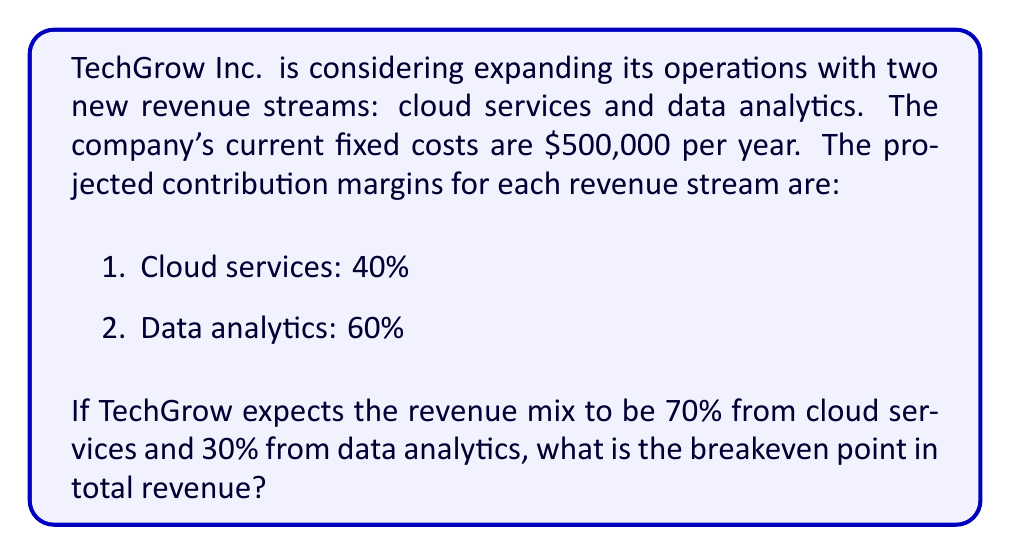Can you answer this question? To solve this problem, we'll follow these steps:

1. Calculate the weighted average contribution margin:
   Let $x$ be the weighted average contribution margin.
   $$x = (0.70 \times 0.40) + (0.30 \times 0.60)$$
   $$x = 0.28 + 0.18 = 0.46 = 46\%$$

2. Use the breakeven formula:
   Breakeven point = Fixed costs ÷ Weighted average contribution margin
   
   Let $y$ be the breakeven point in total revenue.
   $$y = \frac{\text{Fixed costs}}{\text{Weighted average contribution margin}}$$
   
   $$y = \frac{\$500,000}{0.46}$$

3. Calculate the result:
   $$y = \$1,086,956.52$$

4. Round to the nearest dollar:
   $$y = \$1,086,957$$

Therefore, TechGrow Inc. needs to generate $1,086,957 in total revenue to break even with the new revenue streams.
Answer: $1,086,957 